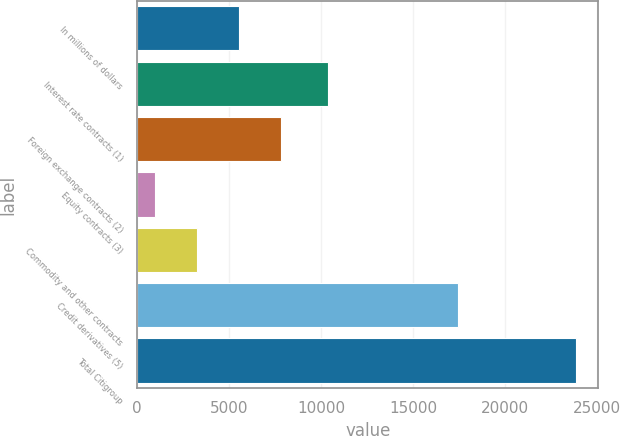Convert chart. <chart><loc_0><loc_0><loc_500><loc_500><bar_chart><fcel>In millions of dollars<fcel>Interest rate contracts (1)<fcel>Foreign exchange contracts (2)<fcel>Equity contracts (3)<fcel>Commodity and other contracts<fcel>Credit derivatives (5)<fcel>Total Citigroup<nl><fcel>5544.2<fcel>10369<fcel>7837.3<fcel>958<fcel>3251.1<fcel>17453<fcel>23889<nl></chart> 